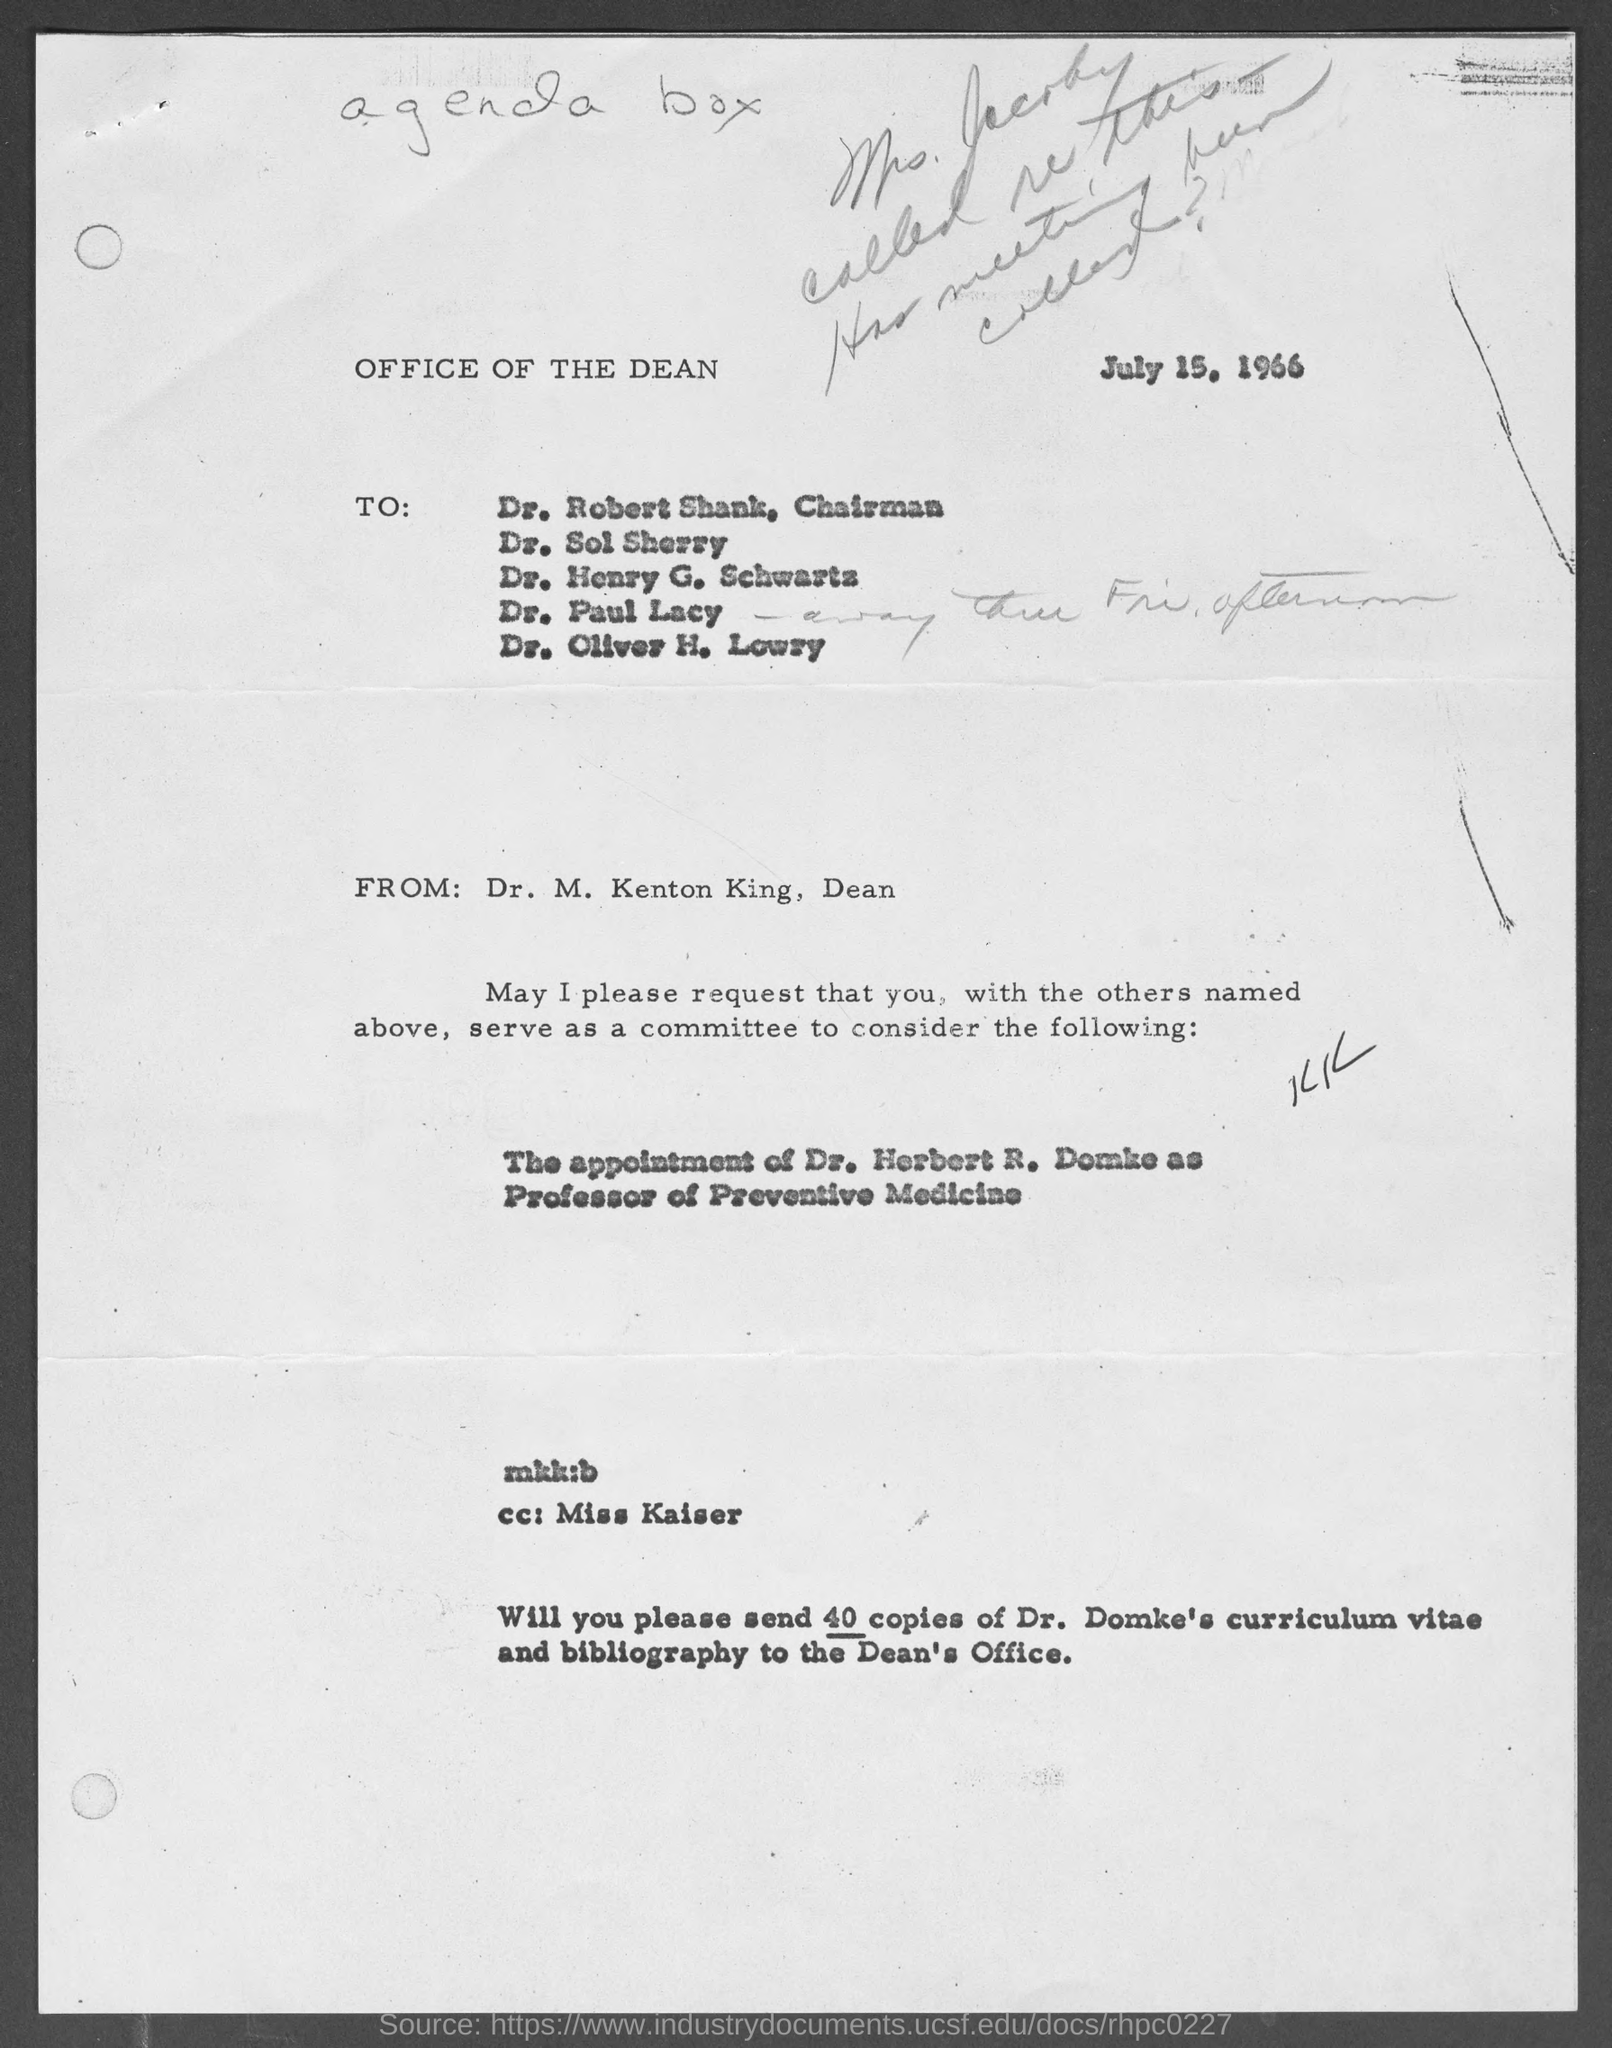Draw attention to some important aspects in this diagram. Dr. Robert Shank holds the position of Chairman. Dr. M. Kenton King is the Dean. The letter is dated July 15, 1966. 